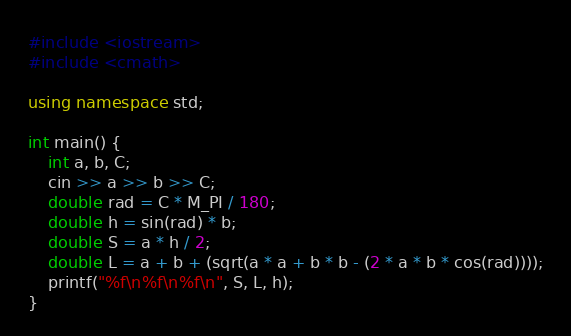<code> <loc_0><loc_0><loc_500><loc_500><_C++_>#include <iostream>
#include <cmath>

using namespace std;

int main() {
    int a, b, C;
    cin >> a >> b >> C;
    double rad = C * M_PI / 180;
    double h = sin(rad) * b;
    double S = a * h / 2;
    double L = a + b + (sqrt(a * a + b * b - (2 * a * b * cos(rad))));
    printf("%f\n%f\n%f\n", S, L, h);
}
</code> 